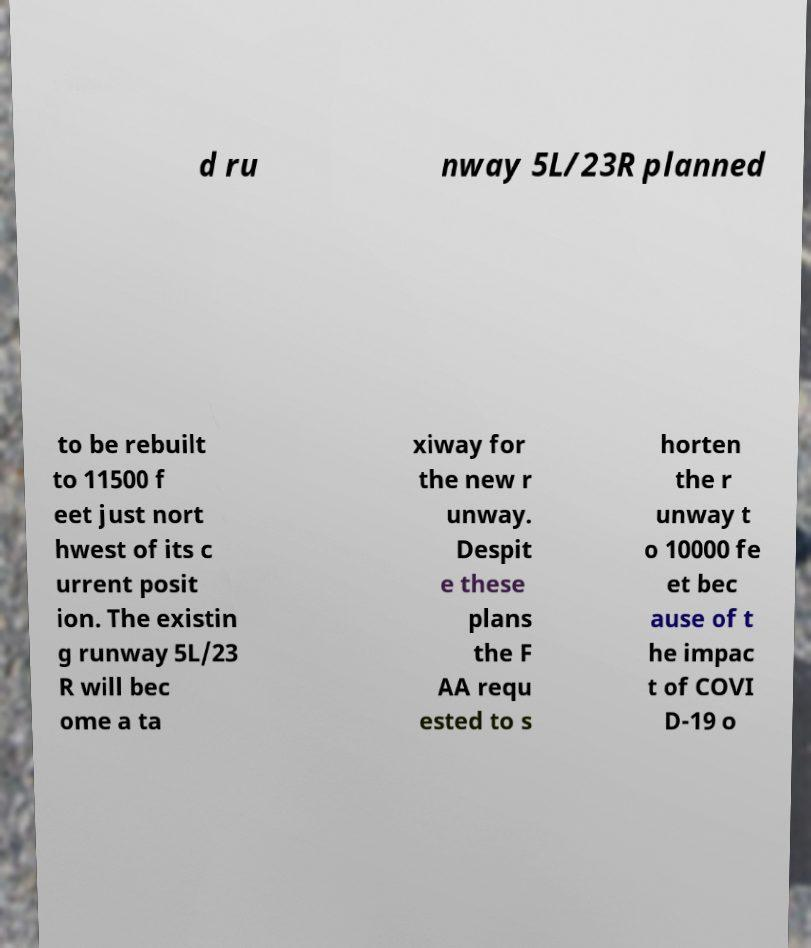Can you accurately transcribe the text from the provided image for me? d ru nway 5L/23R planned to be rebuilt to 11500 f eet just nort hwest of its c urrent posit ion. The existin g runway 5L/23 R will bec ome a ta xiway for the new r unway. Despit e these plans the F AA requ ested to s horten the r unway t o 10000 fe et bec ause of t he impac t of COVI D-19 o 